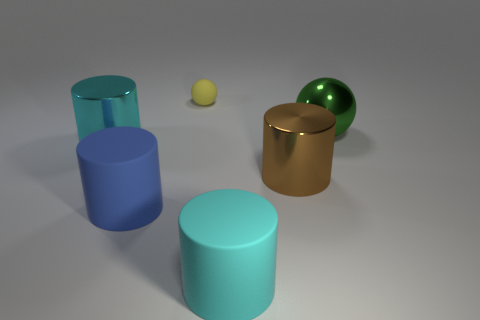Can you tell the positioning of the objects relative to each other? Certainly, the objects are arranged with the three cylinders in the foreground forming a loose triangular formation. The brown cylinder and green sphere are closer to each other near the center, while the small yellow sphere is off to the side, a bit further in the background. 